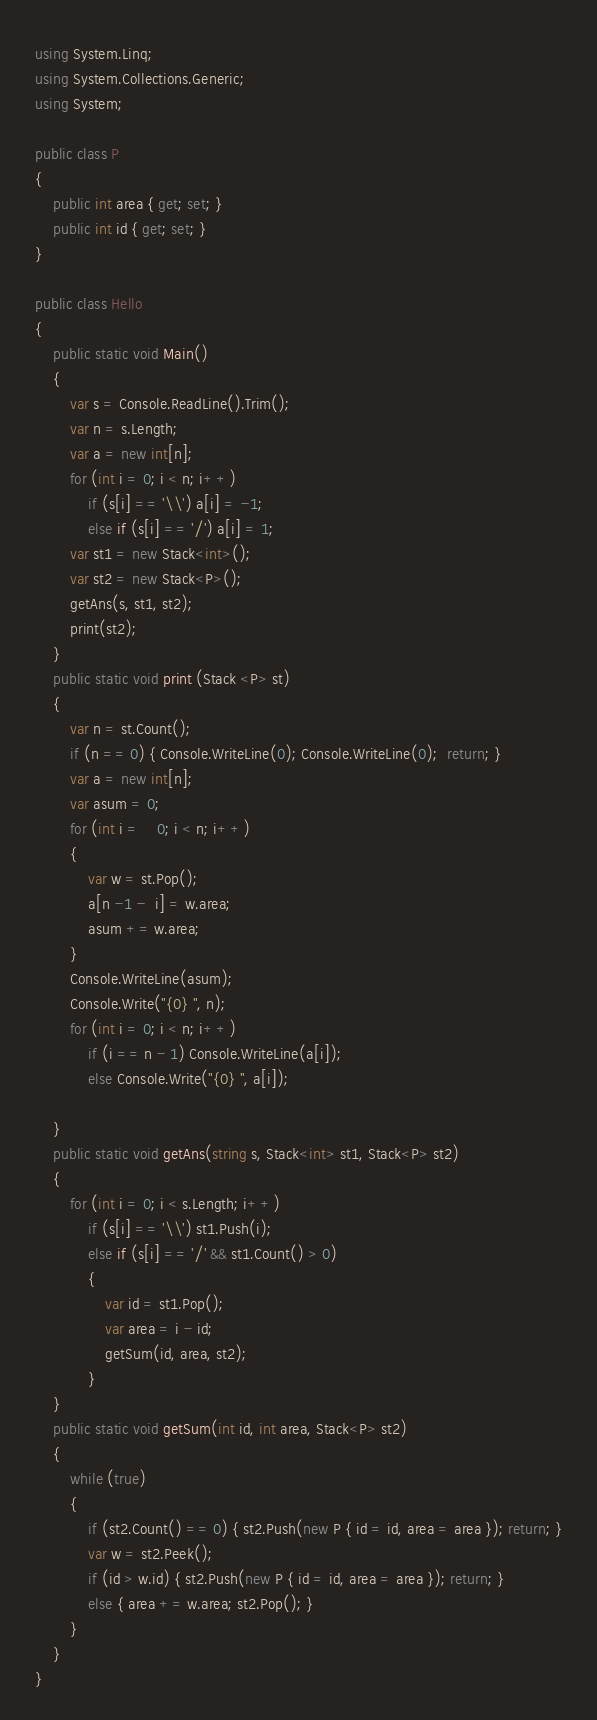Convert code to text. <code><loc_0><loc_0><loc_500><loc_500><_C#_>using System.Linq;
using System.Collections.Generic;
using System;

public class P
{
    public int area { get; set; }
    public int id { get; set; }
}

public class Hello
{
    public static void Main()
    {
        var s = Console.ReadLine().Trim();
        var n = s.Length;
        var a = new int[n];
        for (int i = 0; i < n; i++)
            if (s[i] == '\\') a[i] = -1;
            else if (s[i] == '/') a[i] = 1;
        var st1 = new Stack<int>();
        var st2 = new Stack<P>();
        getAns(s, st1, st2);
        print(st2);
    }
    public static void print (Stack <P> st)
    {
        var n = st.Count();
        if (n == 0) { Console.WriteLine(0); Console.WriteLine(0);  return; }
        var a = new int[n];
        var asum = 0;
        for (int i =    0; i < n; i++)
        {
            var w = st.Pop();
            a[n -1 -  i] = w.area;
            asum += w.area;
        }
        Console.WriteLine(asum);
        Console.Write("{0} ", n);
        for (int i = 0; i < n; i++)
            if (i == n - 1) Console.WriteLine(a[i]);
            else Console.Write("{0} ", a[i]);

    }
    public static void getAns(string s, Stack<int> st1, Stack<P> st2)
    {
        for (int i = 0; i < s.Length; i++)
            if (s[i] == '\\') st1.Push(i);
            else if (s[i] == '/' && st1.Count() > 0)
            {
                var id = st1.Pop();
                var area = i - id;
                getSum(id, area, st2);
            }
    }
    public static void getSum(int id, int area, Stack<P> st2)
    {
        while (true)
        {
            if (st2.Count() == 0) { st2.Push(new P { id = id, area = area }); return; }
            var w = st2.Peek();
            if (id > w.id) { st2.Push(new P { id = id, area = area }); return; }
            else { area += w.area; st2.Pop(); }
        }
    }
}

</code> 